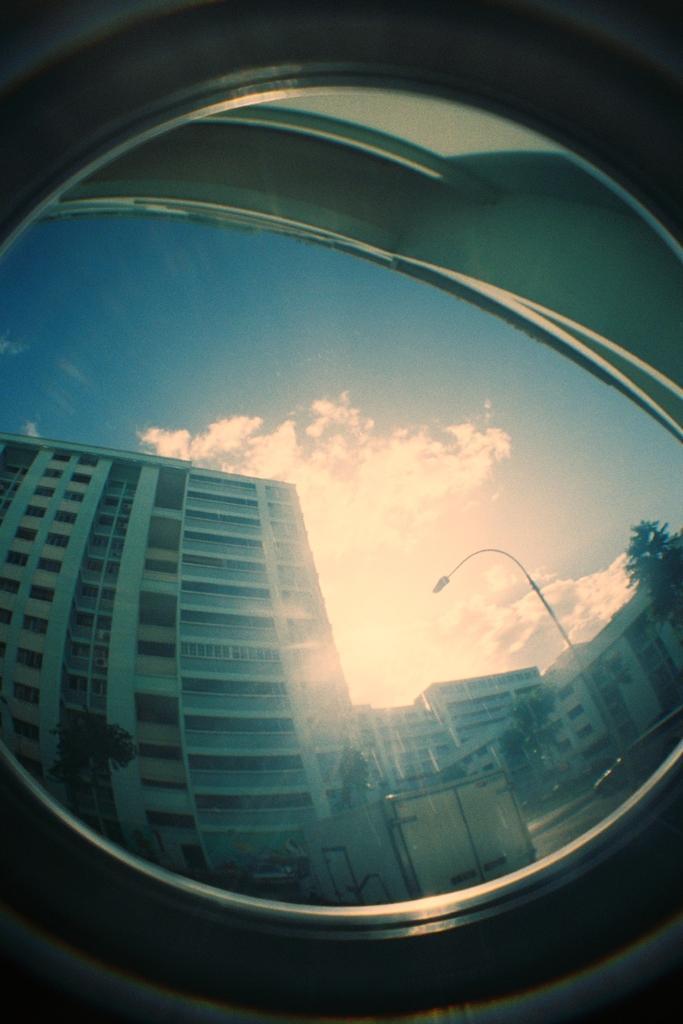How would you summarize this image in a sentence or two? It is 360 degrees picture,in a mirror there is a sky and many buildings are being reflected. 